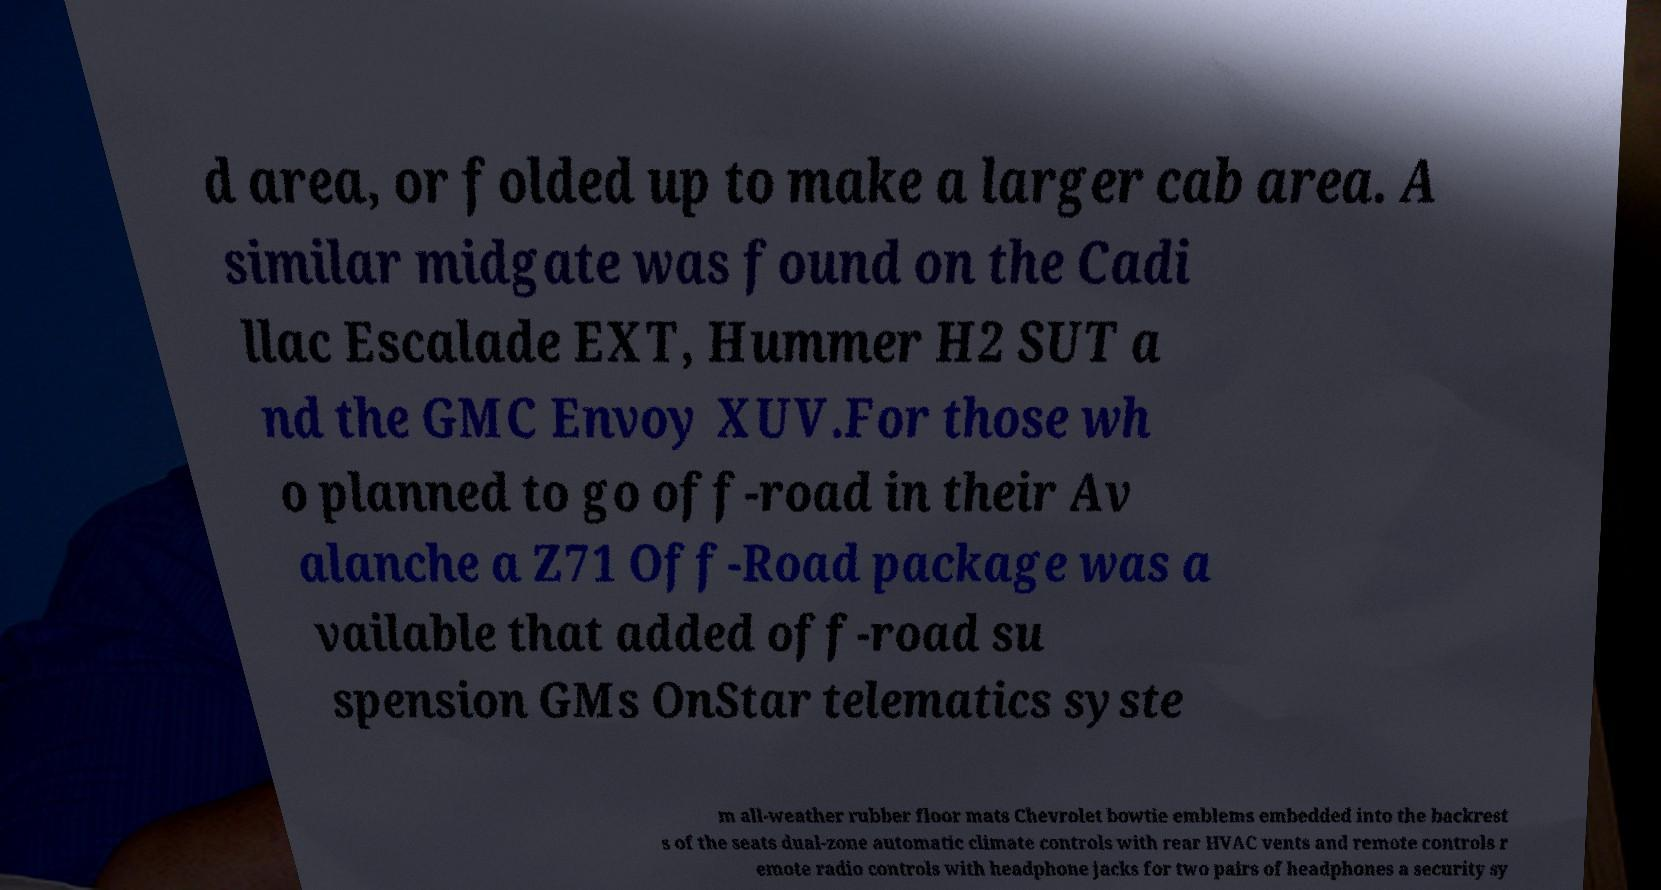I need the written content from this picture converted into text. Can you do that? d area, or folded up to make a larger cab area. A similar midgate was found on the Cadi llac Escalade EXT, Hummer H2 SUT a nd the GMC Envoy XUV.For those wh o planned to go off-road in their Av alanche a Z71 Off-Road package was a vailable that added off-road su spension GMs OnStar telematics syste m all-weather rubber floor mats Chevrolet bowtie emblems embedded into the backrest s of the seats dual-zone automatic climate controls with rear HVAC vents and remote controls r emote radio controls with headphone jacks for two pairs of headphones a security sy 